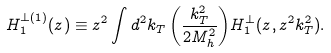<formula> <loc_0><loc_0><loc_500><loc_500>H _ { 1 } ^ { \perp ( 1 ) } ( z ) \equiv z ^ { 2 } \int d ^ { 2 } k _ { T } \, { \left ( \frac { k _ { T } ^ { 2 } } { 2 M ^ { 2 } _ { h } } \right ) } H _ { 1 } ^ { \perp } ( z , z ^ { 2 } k _ { T } ^ { 2 } ) .</formula> 